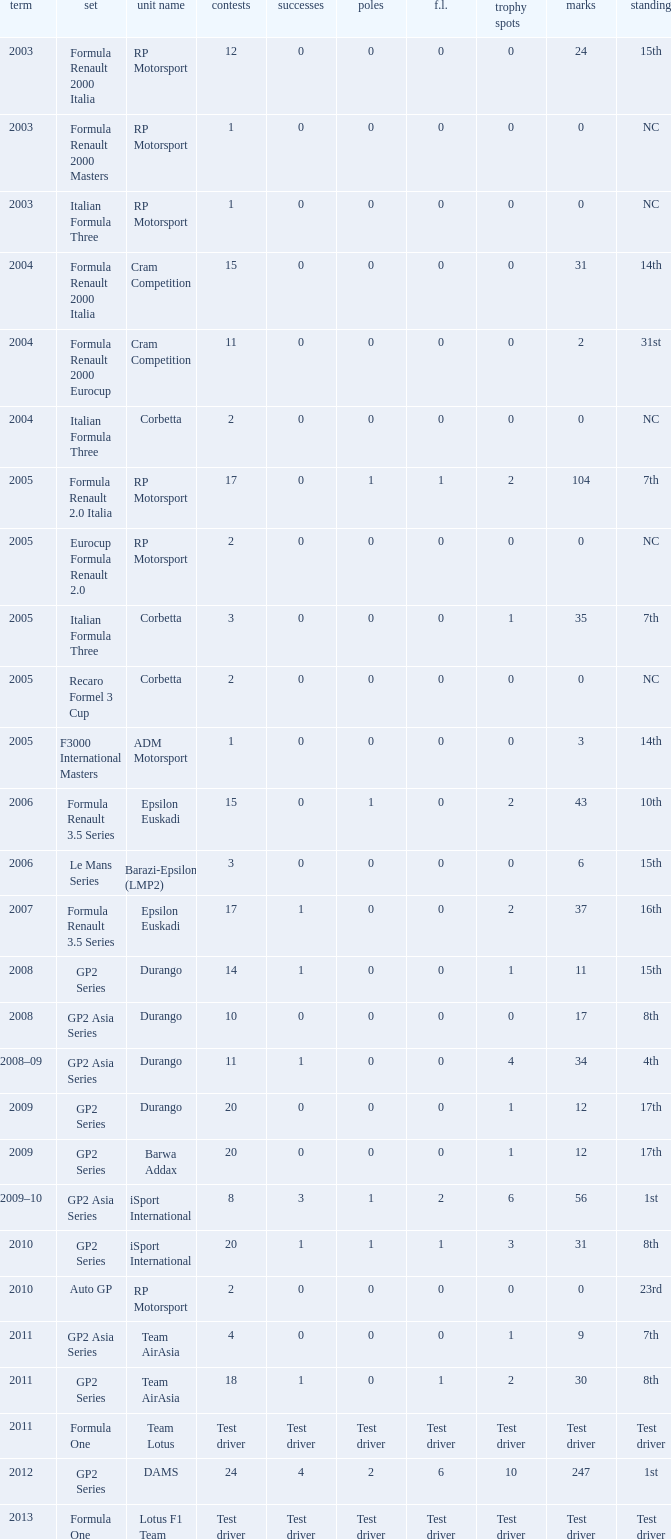What is the number of poles with 4 races? 0.0. 